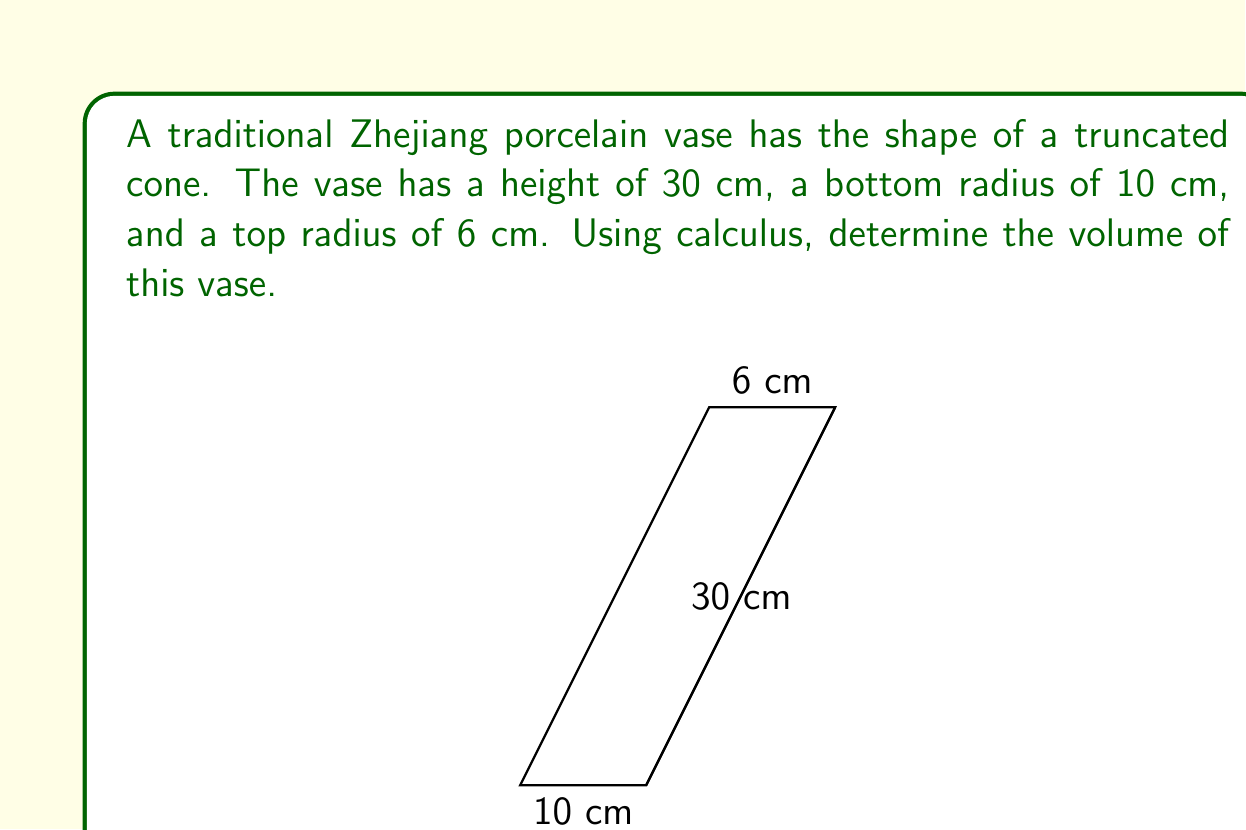Solve this math problem. To find the volume of the truncated cone using calculus, we'll use the method of cylindrical shells:

1) First, let's set up our coordinate system. Let the x-axis be along the base of the cone, and the y-axis be the height.

2) The radius at any height y is given by the equation of a line:
   $r = 10 - \frac{4y}{30} = 10 - \frac{2y}{15}$

3) The volume of a cylindrical shell is given by $dV = 2\pi r h dy$, where r is the radius and h is the height of the shell.

4) Substituting our radius equation:
   $dV = 2\pi (10 - \frac{2y}{15}) (30-y) dy$

5) Now we integrate from y = 0 to y = 30:
   $$V = \int_0^{30} 2\pi (10 - \frac{2y}{15}) (30-y) dy$$

6) Expanding the integrand:
   $$V = 2\pi \int_0^{30} (300 - 10y - 60 + 2y - \frac{2y^2}{15}) dy$$
   $$V = 2\pi \int_0^{30} (240 - 8y - \frac{2y^2}{15}) dy$$

7) Integrating:
   $$V = 2\pi [240y - 4y^2 - \frac{2y^3}{45}]_0^{30}$$

8) Evaluating the limits:
   $$V = 2\pi [(240 \cdot 30 - 4 \cdot 30^2 - \frac{2 \cdot 30^3}{45}) - (0)]$$
   $$V = 2\pi (7200 - 3600 - 1200)$$
   $$V = 2\pi \cdot 2400$$
   $$V = 4800\pi$$

9) Therefore, the volume is $4800\pi$ cubic centimeters.
Answer: $4800\pi$ cm³ 